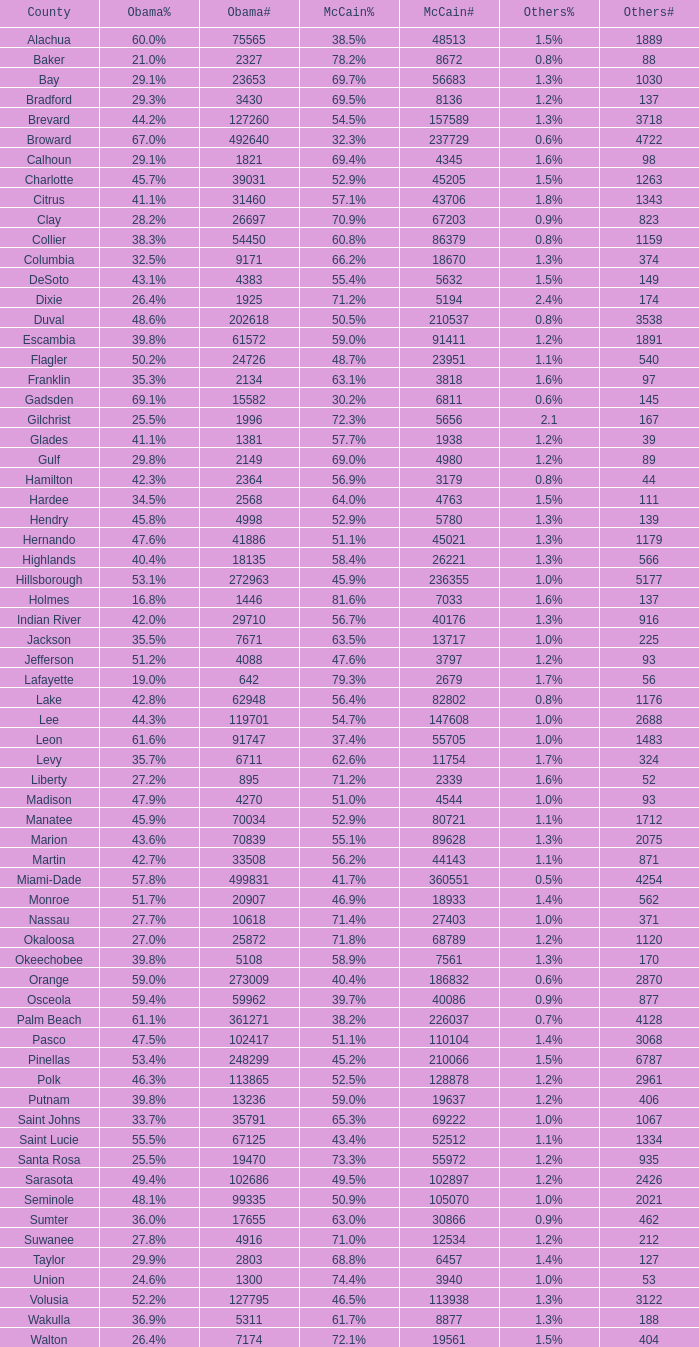Would you mind parsing the complete table? {'header': ['County', 'Obama%', 'Obama#', 'McCain%', 'McCain#', 'Others%', 'Others#'], 'rows': [['Alachua', '60.0%', '75565', '38.5%', '48513', '1.5%', '1889'], ['Baker', '21.0%', '2327', '78.2%', '8672', '0.8%', '88'], ['Bay', '29.1%', '23653', '69.7%', '56683', '1.3%', '1030'], ['Bradford', '29.3%', '3430', '69.5%', '8136', '1.2%', '137'], ['Brevard', '44.2%', '127260', '54.5%', '157589', '1.3%', '3718'], ['Broward', '67.0%', '492640', '32.3%', '237729', '0.6%', '4722'], ['Calhoun', '29.1%', '1821', '69.4%', '4345', '1.6%', '98'], ['Charlotte', '45.7%', '39031', '52.9%', '45205', '1.5%', '1263'], ['Citrus', '41.1%', '31460', '57.1%', '43706', '1.8%', '1343'], ['Clay', '28.2%', '26697', '70.9%', '67203', '0.9%', '823'], ['Collier', '38.3%', '54450', '60.8%', '86379', '0.8%', '1159'], ['Columbia', '32.5%', '9171', '66.2%', '18670', '1.3%', '374'], ['DeSoto', '43.1%', '4383', '55.4%', '5632', '1.5%', '149'], ['Dixie', '26.4%', '1925', '71.2%', '5194', '2.4%', '174'], ['Duval', '48.6%', '202618', '50.5%', '210537', '0.8%', '3538'], ['Escambia', '39.8%', '61572', '59.0%', '91411', '1.2%', '1891'], ['Flagler', '50.2%', '24726', '48.7%', '23951', '1.1%', '540'], ['Franklin', '35.3%', '2134', '63.1%', '3818', '1.6%', '97'], ['Gadsden', '69.1%', '15582', '30.2%', '6811', '0.6%', '145'], ['Gilchrist', '25.5%', '1996', '72.3%', '5656', '2.1', '167'], ['Glades', '41.1%', '1381', '57.7%', '1938', '1.2%', '39'], ['Gulf', '29.8%', '2149', '69.0%', '4980', '1.2%', '89'], ['Hamilton', '42.3%', '2364', '56.9%', '3179', '0.8%', '44'], ['Hardee', '34.5%', '2568', '64.0%', '4763', '1.5%', '111'], ['Hendry', '45.8%', '4998', '52.9%', '5780', '1.3%', '139'], ['Hernando', '47.6%', '41886', '51.1%', '45021', '1.3%', '1179'], ['Highlands', '40.4%', '18135', '58.4%', '26221', '1.3%', '566'], ['Hillsborough', '53.1%', '272963', '45.9%', '236355', '1.0%', '5177'], ['Holmes', '16.8%', '1446', '81.6%', '7033', '1.6%', '137'], ['Indian River', '42.0%', '29710', '56.7%', '40176', '1.3%', '916'], ['Jackson', '35.5%', '7671', '63.5%', '13717', '1.0%', '225'], ['Jefferson', '51.2%', '4088', '47.6%', '3797', '1.2%', '93'], ['Lafayette', '19.0%', '642', '79.3%', '2679', '1.7%', '56'], ['Lake', '42.8%', '62948', '56.4%', '82802', '0.8%', '1176'], ['Lee', '44.3%', '119701', '54.7%', '147608', '1.0%', '2688'], ['Leon', '61.6%', '91747', '37.4%', '55705', '1.0%', '1483'], ['Levy', '35.7%', '6711', '62.6%', '11754', '1.7%', '324'], ['Liberty', '27.2%', '895', '71.2%', '2339', '1.6%', '52'], ['Madison', '47.9%', '4270', '51.0%', '4544', '1.0%', '93'], ['Manatee', '45.9%', '70034', '52.9%', '80721', '1.1%', '1712'], ['Marion', '43.6%', '70839', '55.1%', '89628', '1.3%', '2075'], ['Martin', '42.7%', '33508', '56.2%', '44143', '1.1%', '871'], ['Miami-Dade', '57.8%', '499831', '41.7%', '360551', '0.5%', '4254'], ['Monroe', '51.7%', '20907', '46.9%', '18933', '1.4%', '562'], ['Nassau', '27.7%', '10618', '71.4%', '27403', '1.0%', '371'], ['Okaloosa', '27.0%', '25872', '71.8%', '68789', '1.2%', '1120'], ['Okeechobee', '39.8%', '5108', '58.9%', '7561', '1.3%', '170'], ['Orange', '59.0%', '273009', '40.4%', '186832', '0.6%', '2870'], ['Osceola', '59.4%', '59962', '39.7%', '40086', '0.9%', '877'], ['Palm Beach', '61.1%', '361271', '38.2%', '226037', '0.7%', '4128'], ['Pasco', '47.5%', '102417', '51.1%', '110104', '1.4%', '3068'], ['Pinellas', '53.4%', '248299', '45.2%', '210066', '1.5%', '6787'], ['Polk', '46.3%', '113865', '52.5%', '128878', '1.2%', '2961'], ['Putnam', '39.8%', '13236', '59.0%', '19637', '1.2%', '406'], ['Saint Johns', '33.7%', '35791', '65.3%', '69222', '1.0%', '1067'], ['Saint Lucie', '55.5%', '67125', '43.4%', '52512', '1.1%', '1334'], ['Santa Rosa', '25.5%', '19470', '73.3%', '55972', '1.2%', '935'], ['Sarasota', '49.4%', '102686', '49.5%', '102897', '1.2%', '2426'], ['Seminole', '48.1%', '99335', '50.9%', '105070', '1.0%', '2021'], ['Sumter', '36.0%', '17655', '63.0%', '30866', '0.9%', '462'], ['Suwanee', '27.8%', '4916', '71.0%', '12534', '1.2%', '212'], ['Taylor', '29.9%', '2803', '68.8%', '6457', '1.4%', '127'], ['Union', '24.6%', '1300', '74.4%', '3940', '1.0%', '53'], ['Volusia', '52.2%', '127795', '46.5%', '113938', '1.3%', '3122'], ['Wakulla', '36.9%', '5311', '61.7%', '8877', '1.3%', '188'], ['Walton', '26.4%', '7174', '72.1%', '19561', '1.5%', '404']]} What were the number of voters McCain had when Obama had 895? 2339.0. 